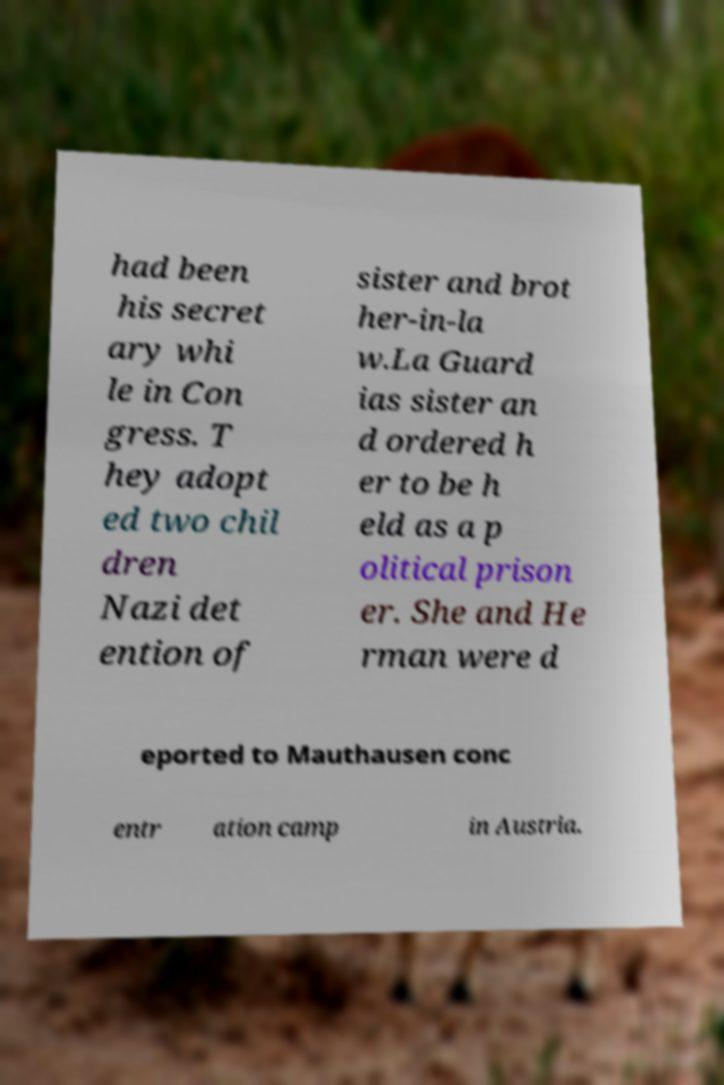Could you assist in decoding the text presented in this image and type it out clearly? had been his secret ary whi le in Con gress. T hey adopt ed two chil dren Nazi det ention of sister and brot her-in-la w.La Guard ias sister an d ordered h er to be h eld as a p olitical prison er. She and He rman were d eported to Mauthausen conc entr ation camp in Austria. 